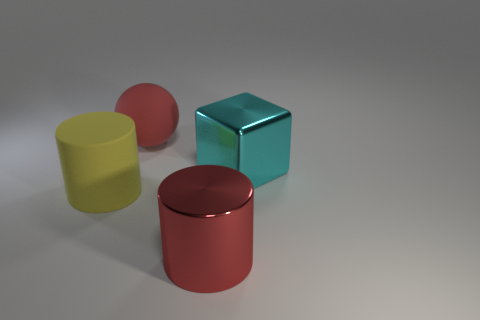Is the number of big red shiny objects that are behind the large cube the same as the number of big things that are in front of the red rubber ball?
Make the answer very short. No. Are there any cyan shiny objects that are in front of the big red thing in front of the cyan shiny thing?
Make the answer very short. No. The cyan metal thing has what shape?
Ensure brevity in your answer.  Cube. There is a matte thing to the right of the big cylinder to the left of the large red matte ball; what size is it?
Offer a terse response. Large. Are there fewer big yellow cylinders right of the red matte sphere than red matte balls to the left of the cyan shiny thing?
Provide a succinct answer. Yes. The large shiny block has what color?
Offer a terse response. Cyan. Is there a cylinder of the same color as the large ball?
Your answer should be very brief. Yes. What shape is the metal object that is to the right of the red object in front of the large cylinder behind the big red metallic object?
Your response must be concise. Cube. What is the material of the large red thing that is behind the cyan cube?
Keep it short and to the point. Rubber. Is the size of the matte sphere the same as the object that is in front of the yellow matte cylinder?
Offer a very short reply. Yes. 